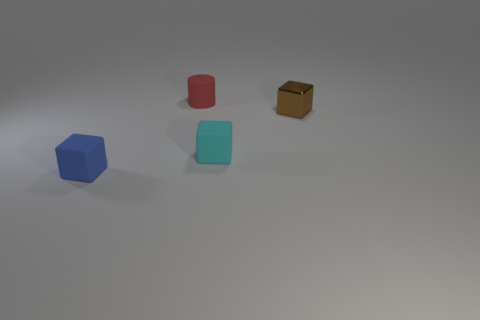Subtract all tiny rubber cubes. How many cubes are left? 1 Add 2 brown cubes. How many objects exist? 6 Subtract all cylinders. How many objects are left? 3 Add 2 gray balls. How many gray balls exist? 2 Subtract 0 red blocks. How many objects are left? 4 Subtract all large purple metal spheres. Subtract all cyan objects. How many objects are left? 3 Add 4 rubber cylinders. How many rubber cylinders are left? 5 